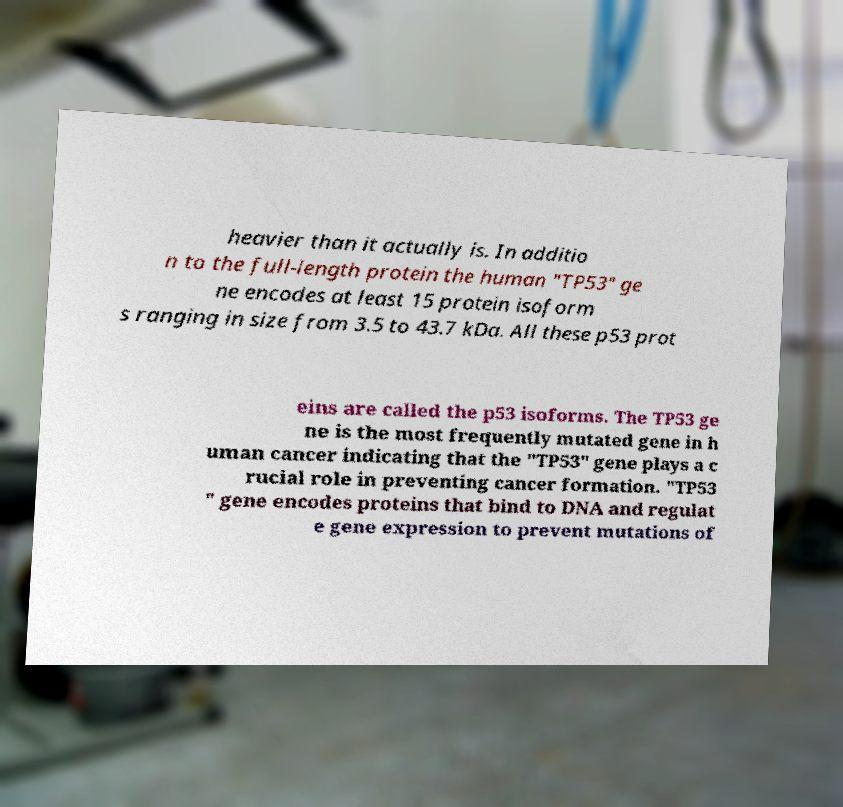Please read and relay the text visible in this image. What does it say? heavier than it actually is. In additio n to the full-length protein the human "TP53" ge ne encodes at least 15 protein isoform s ranging in size from 3.5 to 43.7 kDa. All these p53 prot eins are called the p53 isoforms. The TP53 ge ne is the most frequently mutated gene in h uman cancer indicating that the "TP53" gene plays a c rucial role in preventing cancer formation. "TP53 " gene encodes proteins that bind to DNA and regulat e gene expression to prevent mutations of 